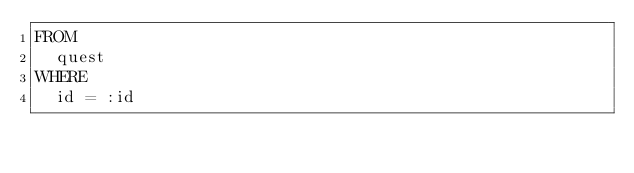Convert code to text. <code><loc_0><loc_0><loc_500><loc_500><_SQL_>FROM
  quest
WHERE
  id = :id

</code> 